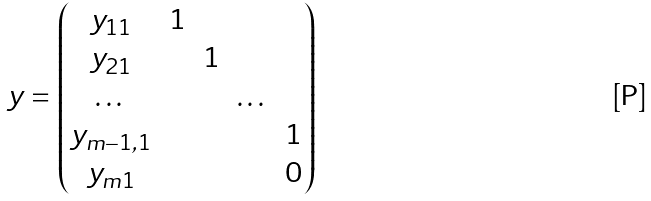<formula> <loc_0><loc_0><loc_500><loc_500>y = \begin{pmatrix} y _ { 1 1 } & 1 & & & \\ y _ { 2 1 } & & 1 & & \\ \dots & & & \dots & \\ y _ { m - 1 , 1 } & & & & 1 \\ y _ { m 1 } & & & & 0 \end{pmatrix}</formula> 